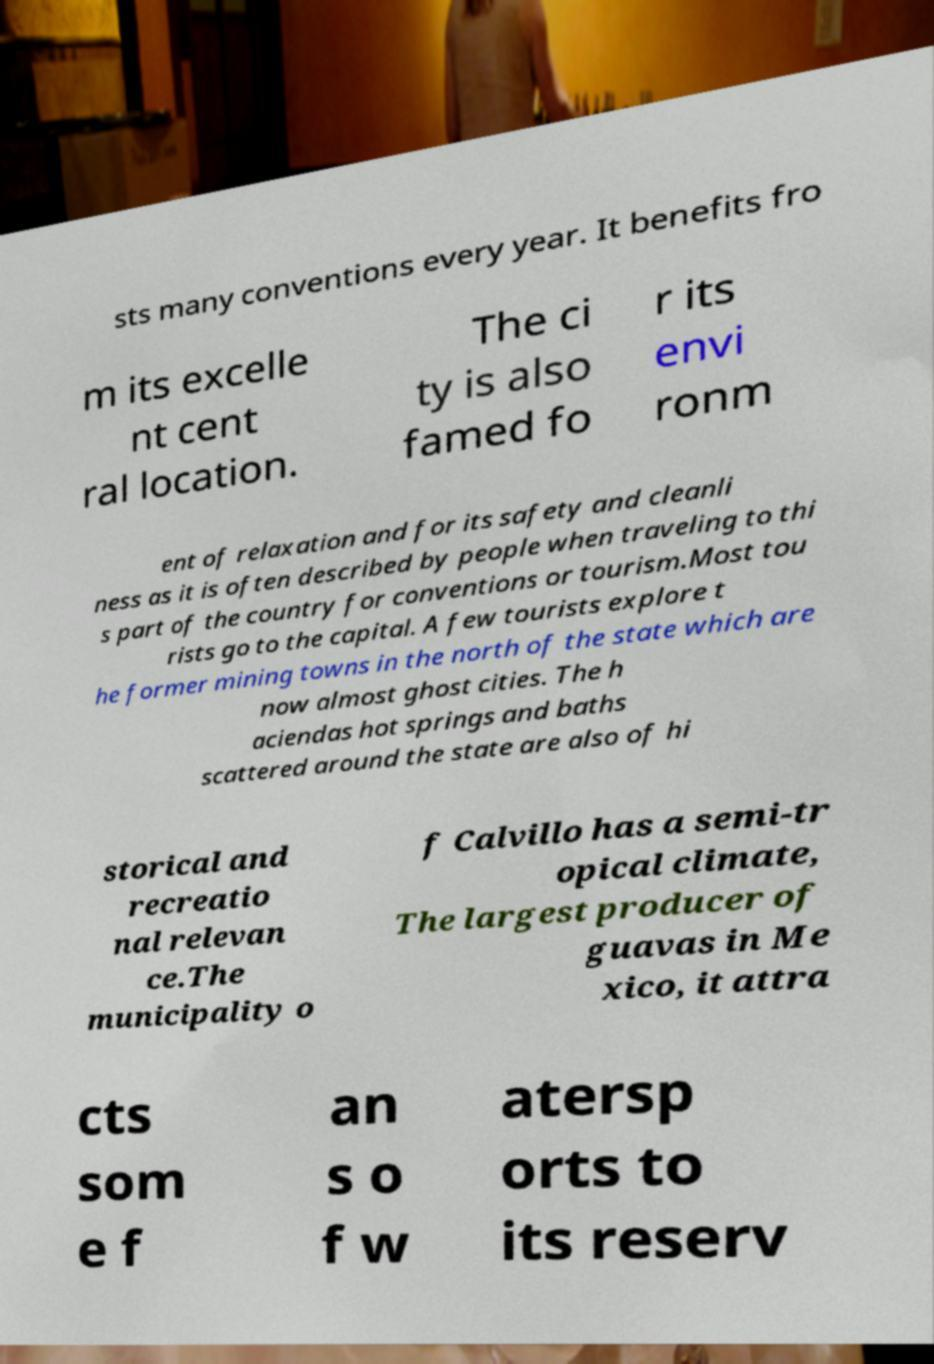What messages or text are displayed in this image? I need them in a readable, typed format. sts many conventions every year. It benefits fro m its excelle nt cent ral location. The ci ty is also famed fo r its envi ronm ent of relaxation and for its safety and cleanli ness as it is often described by people when traveling to thi s part of the country for conventions or tourism.Most tou rists go to the capital. A few tourists explore t he former mining towns in the north of the state which are now almost ghost cities. The h aciendas hot springs and baths scattered around the state are also of hi storical and recreatio nal relevan ce.The municipality o f Calvillo has a semi-tr opical climate, The largest producer of guavas in Me xico, it attra cts som e f an s o f w atersp orts to its reserv 